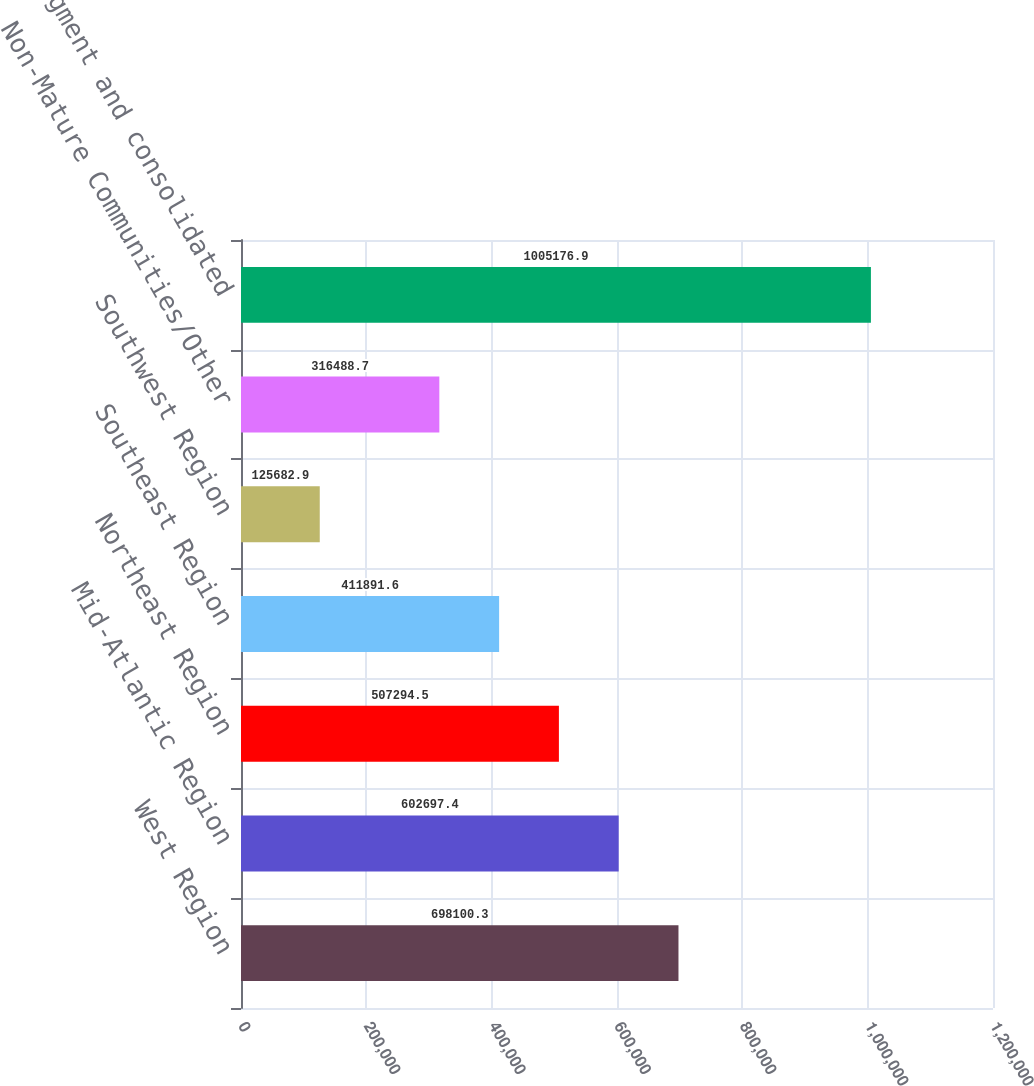<chart> <loc_0><loc_0><loc_500><loc_500><bar_chart><fcel>West Region<fcel>Mid-Atlantic Region<fcel>Northeast Region<fcel>Southeast Region<fcel>Southwest Region<fcel>Non-Mature Communities/Other<fcel>Total segment and consolidated<nl><fcel>698100<fcel>602697<fcel>507294<fcel>411892<fcel>125683<fcel>316489<fcel>1.00518e+06<nl></chart> 